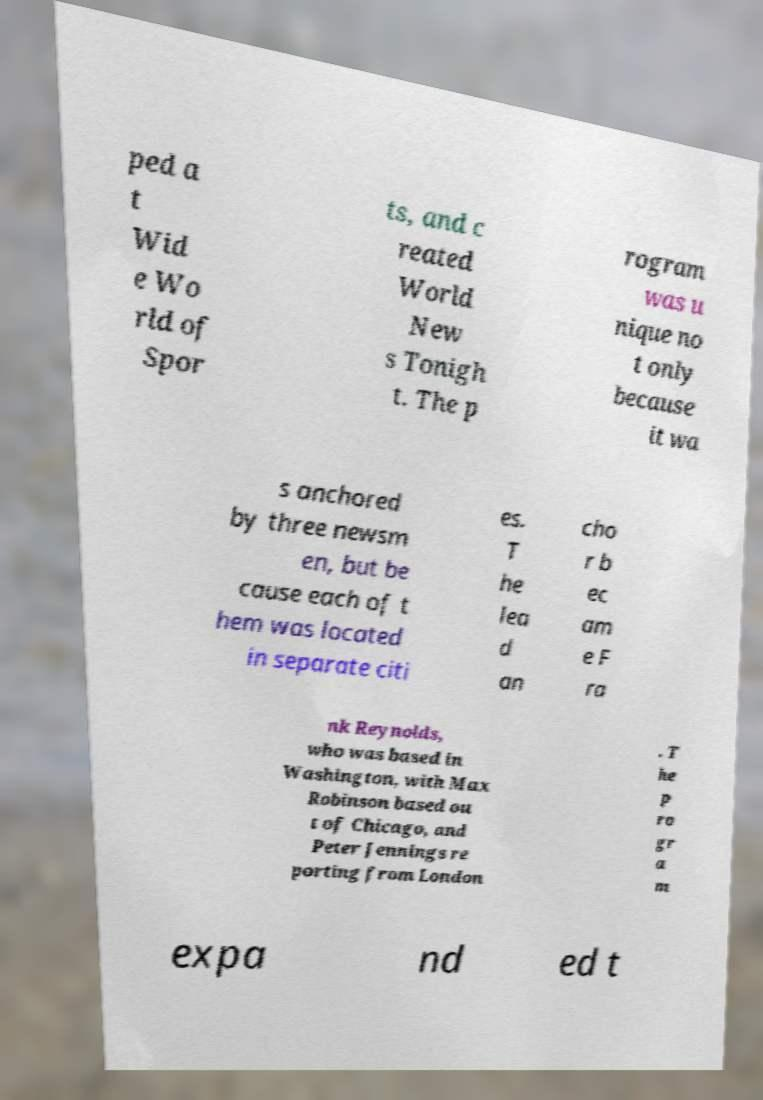I need the written content from this picture converted into text. Can you do that? ped a t Wid e Wo rld of Spor ts, and c reated World New s Tonigh t. The p rogram was u nique no t only because it wa s anchored by three newsm en, but be cause each of t hem was located in separate citi es. T he lea d an cho r b ec am e F ra nk Reynolds, who was based in Washington, with Max Robinson based ou t of Chicago, and Peter Jennings re porting from London . T he p ro gr a m expa nd ed t 